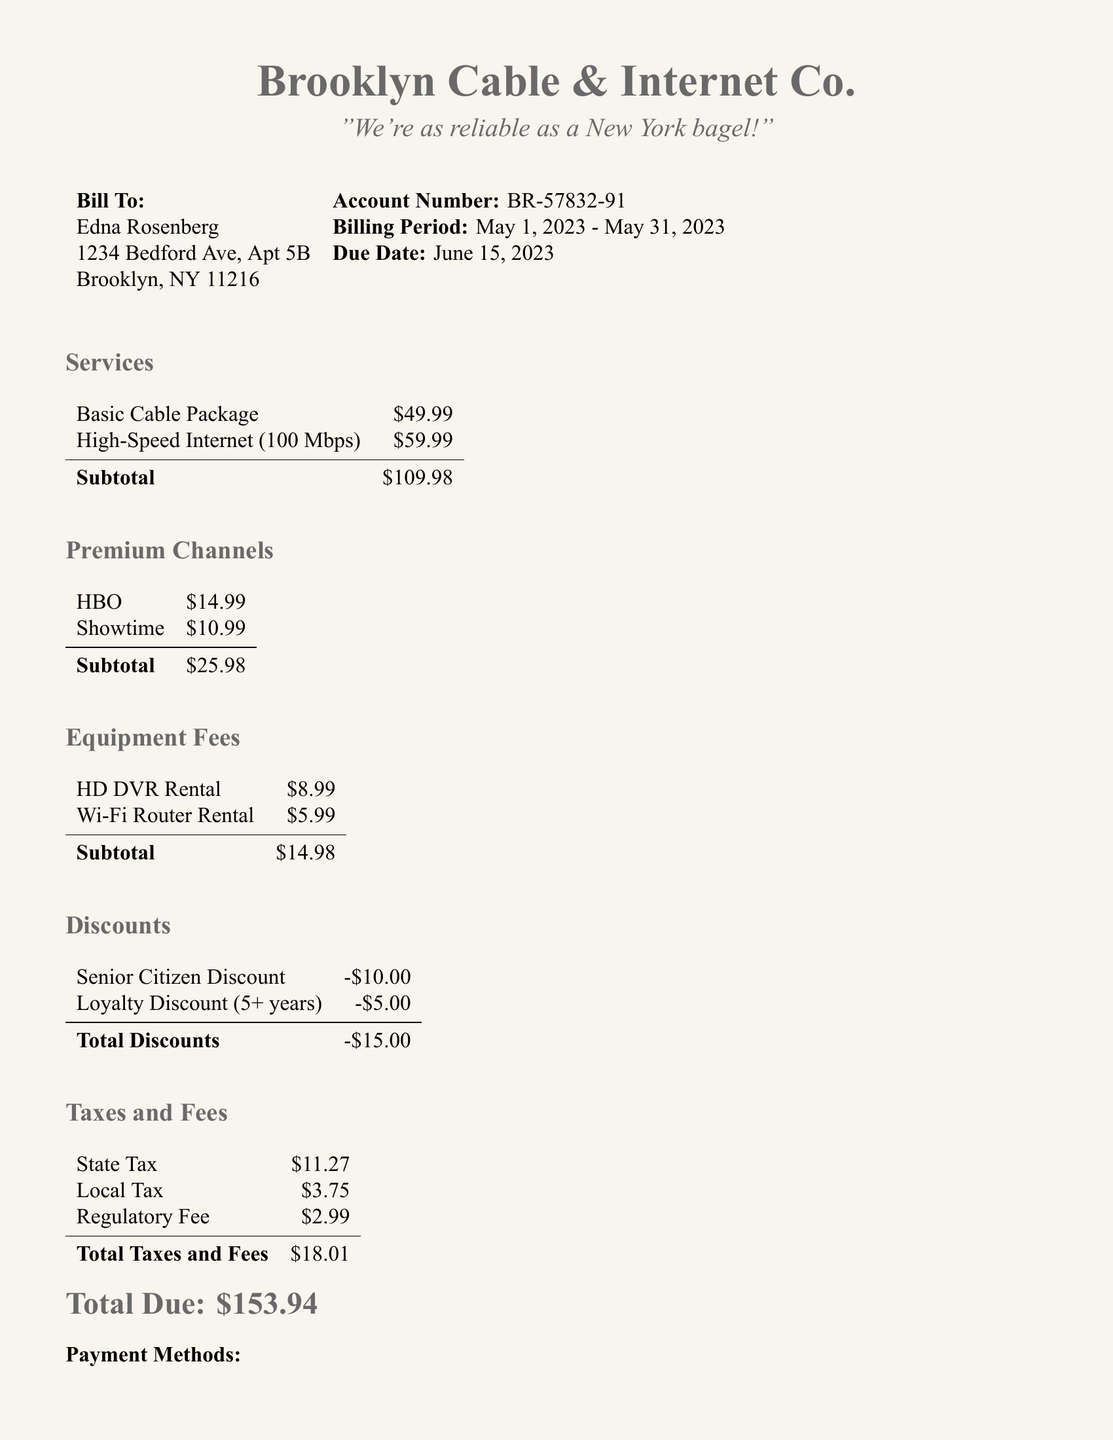What is the total due amount? The total due amount is stated at the bottom of the bill and combines all charges, discounts, and taxes, which amounts to $153.94.
Answer: $153.94 What is the billing period? The billing period mentioned in the document specifies the timeframe of the charges, noted as May 1, 2023 - May 31, 2023.
Answer: May 1, 2023 - May 31, 2023 How much is the Senior Citizen Discount? The Senior Citizen Discount listed is a specific amount deducted from the total bill, which is $10.00.
Answer: $10.00 What services are included in the basic cable package? The document provides an overview of the services included in the basic cable package and states the charge associated with it, which is $49.99. However, it does not specify which channels are included.
Answer: Not specified What is the subtotal for premium channels? The subtotal for premium channels is calculated by adding the charges for HBO and Showtime, totaling $25.98.
Answer: $25.98 What is the total amount of taxes and fees? The total amount of taxes and fees is derived from summing all individual charges listed under that section, which equals $18.01.
Answer: $18.01 How much is the Wi-Fi Router Rental? The Wi-Fi Router Rental fee is specifically itemized in the equipment fees section, which states it is $5.99.
Answer: $5.99 What are the payment methods available? The payment methods section outlines the options for payment, including online, by phone, or by mail, as detailed in the document.
Answer: Online, by phone, or by mail What is the local tax amount? The document specifies a local tax amount that contributes to the total charges, which is $3.75.
Answer: $3.75 